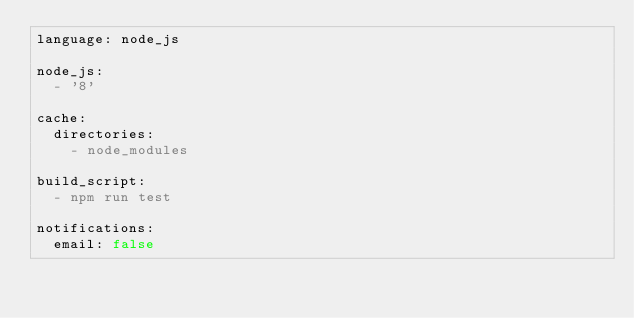<code> <loc_0><loc_0><loc_500><loc_500><_YAML_>language: node_js

node_js:
  - '8'

cache:
  directories:
    - node_modules

build_script:
  - npm run test

notifications:
  email: false</code> 